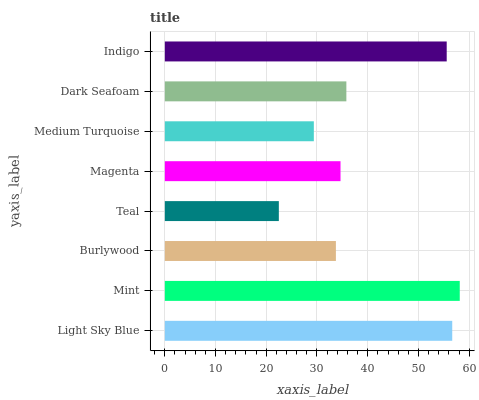Is Teal the minimum?
Answer yes or no. Yes. Is Mint the maximum?
Answer yes or no. Yes. Is Burlywood the minimum?
Answer yes or no. No. Is Burlywood the maximum?
Answer yes or no. No. Is Mint greater than Burlywood?
Answer yes or no. Yes. Is Burlywood less than Mint?
Answer yes or no. Yes. Is Burlywood greater than Mint?
Answer yes or no. No. Is Mint less than Burlywood?
Answer yes or no. No. Is Dark Seafoam the high median?
Answer yes or no. Yes. Is Magenta the low median?
Answer yes or no. Yes. Is Medium Turquoise the high median?
Answer yes or no. No. Is Teal the low median?
Answer yes or no. No. 